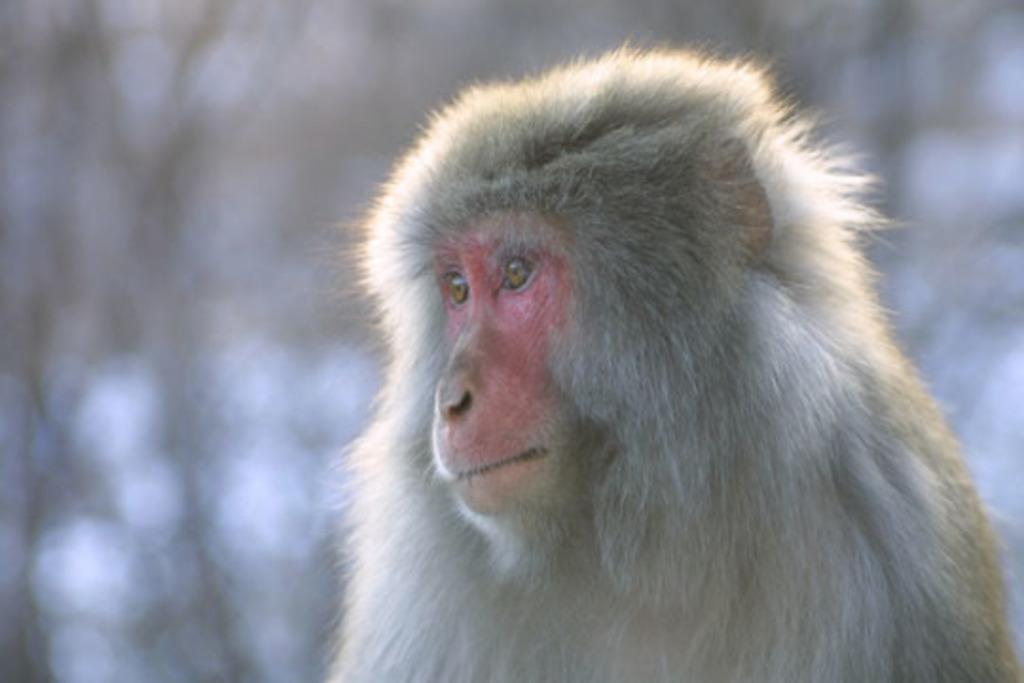What type of animal is in the image? There is a monkey in the image. Can you describe the background of the image? The background of the image appears blurry. How many sisters does the monkey have in the image? There is no mention of sisters in the image, as it only features a monkey. 